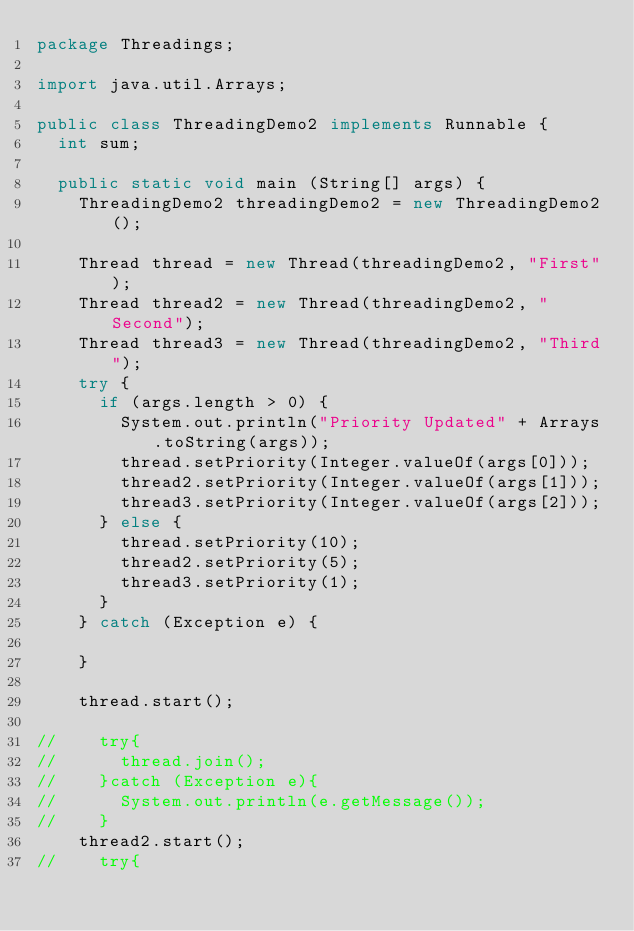Convert code to text. <code><loc_0><loc_0><loc_500><loc_500><_Java_>package Threadings;

import java.util.Arrays;

public class ThreadingDemo2 implements Runnable {
	int sum;
	
	public static void main (String[] args) {
		ThreadingDemo2 threadingDemo2 = new ThreadingDemo2();
		
		Thread thread = new Thread(threadingDemo2, "First");
		Thread thread2 = new Thread(threadingDemo2, "Second");
		Thread thread3 = new Thread(threadingDemo2, "Third");
		try {
			if (args.length > 0) {
				System.out.println("Priority Updated" + Arrays.toString(args));
				thread.setPriority(Integer.valueOf(args[0]));
				thread2.setPriority(Integer.valueOf(args[1]));
				thread3.setPriority(Integer.valueOf(args[2]));
			} else {
				thread.setPriority(10);
				thread2.setPriority(5);
				thread3.setPriority(1);
			}
		} catch (Exception e) {
		
		}
		
		thread.start();

//		try{
//			thread.join();
//		}catch (Exception e){
//			System.out.println(e.getMessage());
//		}
		thread2.start();
//		try{</code> 